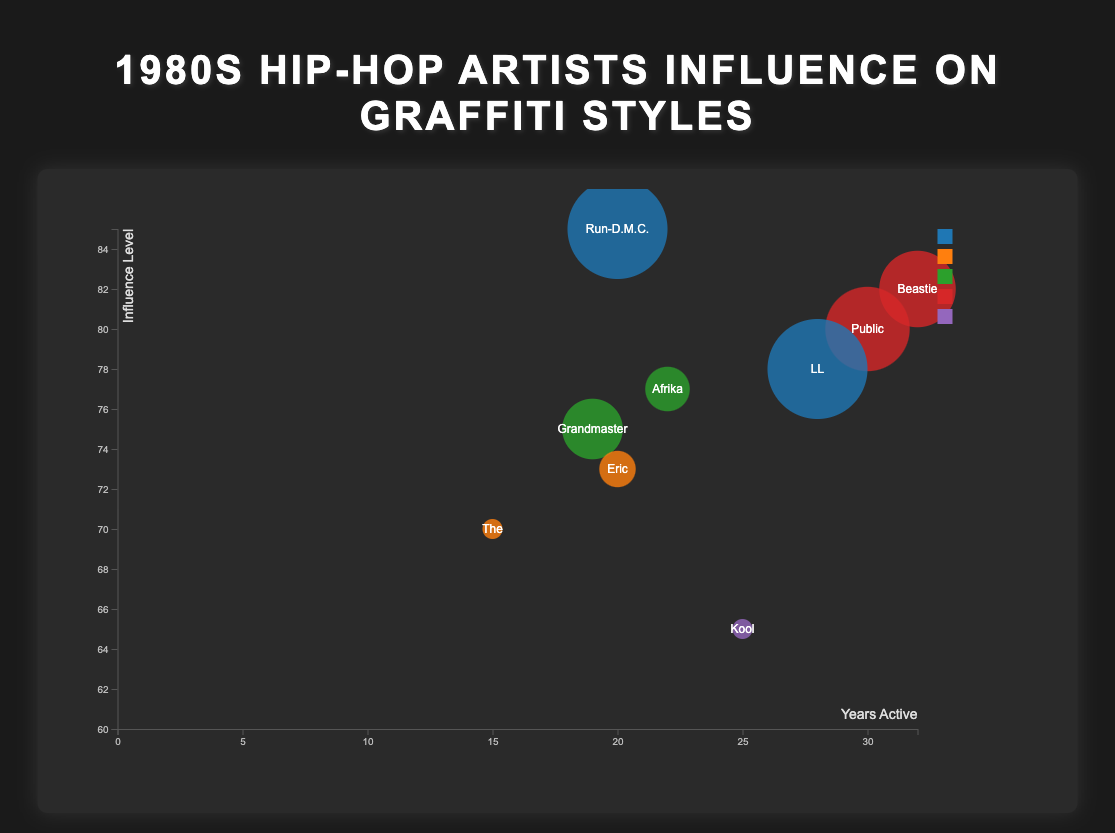what is the title of the chart? The title can be found at the top of the chart displayed in a large font, which summarizes the information presented in the figure.
Answer: 1980s Hip-Hop Artists Influence on Graffiti Styles What are the colors representing different graffiti styles? The legend on the right side of the chart shows different colors for each graffiti style.
Answer: Wildstyle, Blockbuster, Throw-up, Stencil, Sticker Which artist has the highest influence level and what graffiti style do they represent? The highest influence level can be identified by looking at the highest bubble position on the y-axis and identifying the label or hover text.
Answer: Run-D.M.C., Wildstyle How many artists have been active for more than 25 years? This can be found by counting the number of bubbles with x-axis values greater than 25.
Answer: 3 Which artist has the largest bubble, representing the highest pop culture impact? The bubble size represents pop culture impact; by identifying the largest bubble visually, the artist can be found.
Answer: Run-D.M.C Which artists represent the "Stencil" graffiti style, and how do their influence levels compare? Identify the bubbles colored for the "Stencil" style and compare their y-axis positions.
Answer: Public Enemy (80), Beastie Boys (82) What is the average years active for artists with a pop culture impact of 85 or higher? Identify the artists with a pop culture impact of 85 or higher and calculate the average of their years active values. Explanation step: (Run-D.M.C. with 20 years, Grandmaster Flash with 19 years, Public Enemy with 30 years, LL Cool J with 28 years, Beastie Boys with 32 years) Sum = 129, count = 5, average = 129/5
Answer: 25.8 How many graffiti styles are represented in the chart? This can be counted by looking at the unique colors and styles in the legend.
Answer: 5 Who has more influence in graffiti styles, Grandmaster Flash and the Furious Five or Afrika Bambaataa? Compare the y-axis values for both artists to see who has a higher influence level.
Answer: Grandmaster Flash and the Furious Five (75) 